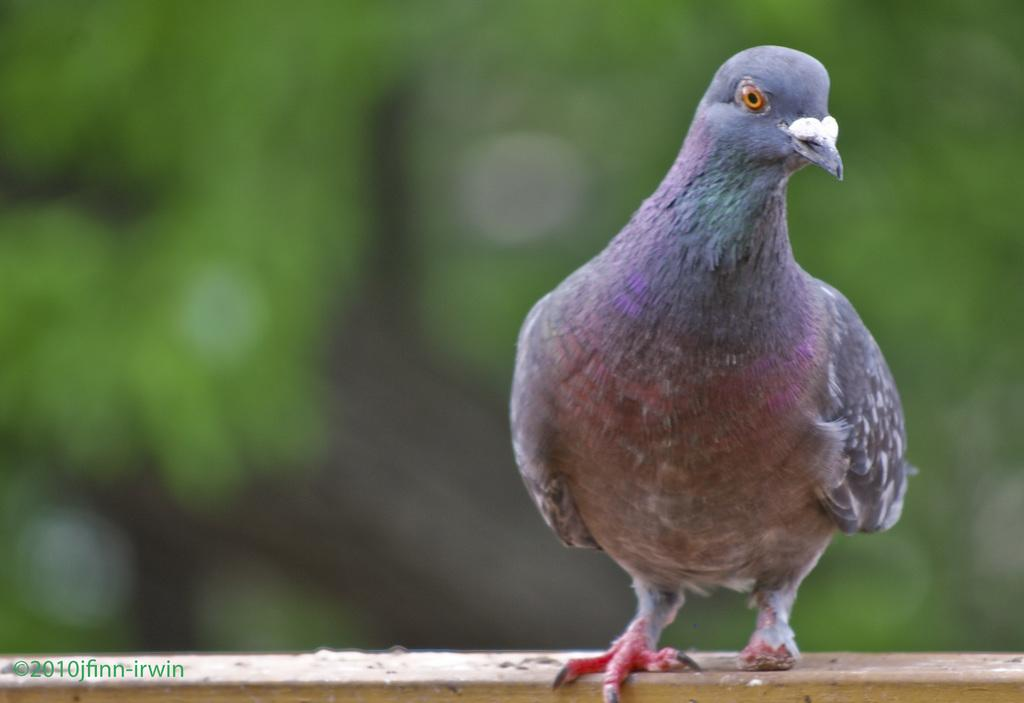What type of animal is in the image? There is a pigeon in the image. Where is the pigeon located? The pigeon is on a wooden stick. What else can be seen in the image besides the pigeon? There is text in the image. What colors are present on the back side of the pigeon? The back side of the pigeon has a brown and green color background. What type of pipe is visible in the image? There is no pipe present in the image. What route does the pigeon take in the image? The image does not depict the pigeon in motion, so it is not possible to determine a route. 